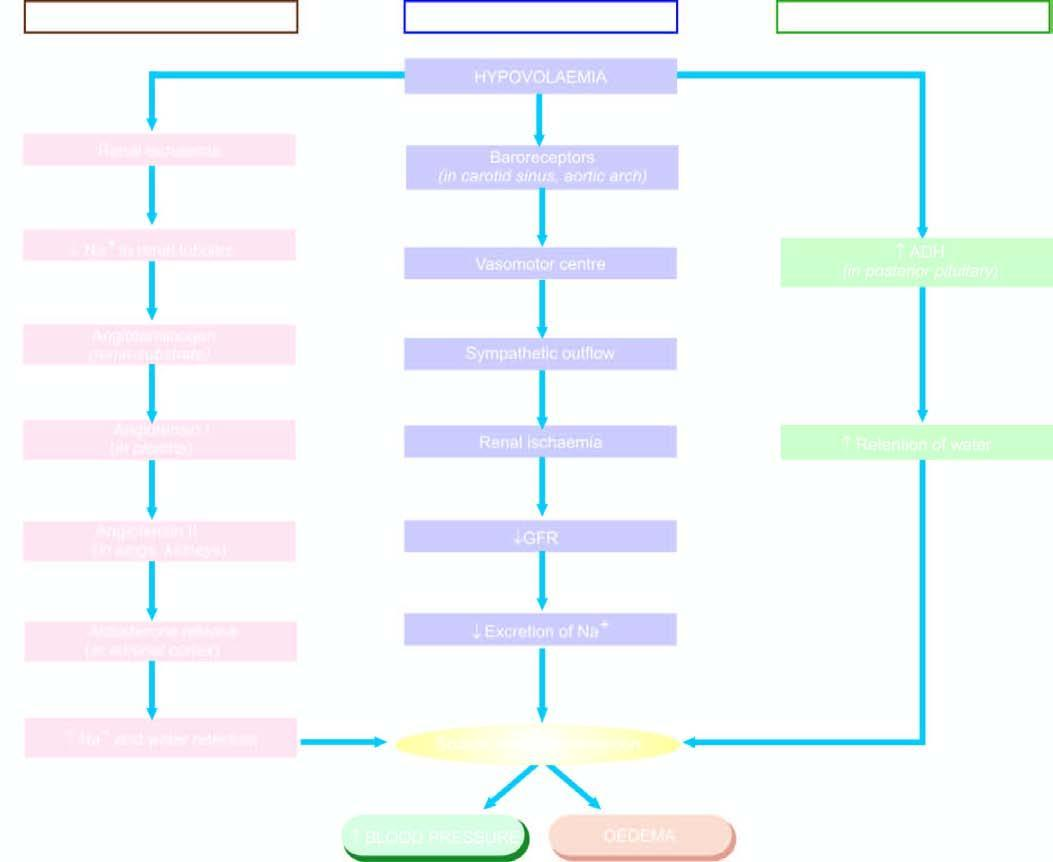what is involved in oedema by sodium and water retention?
Answer the question using a single word or phrase. Mechanisms 